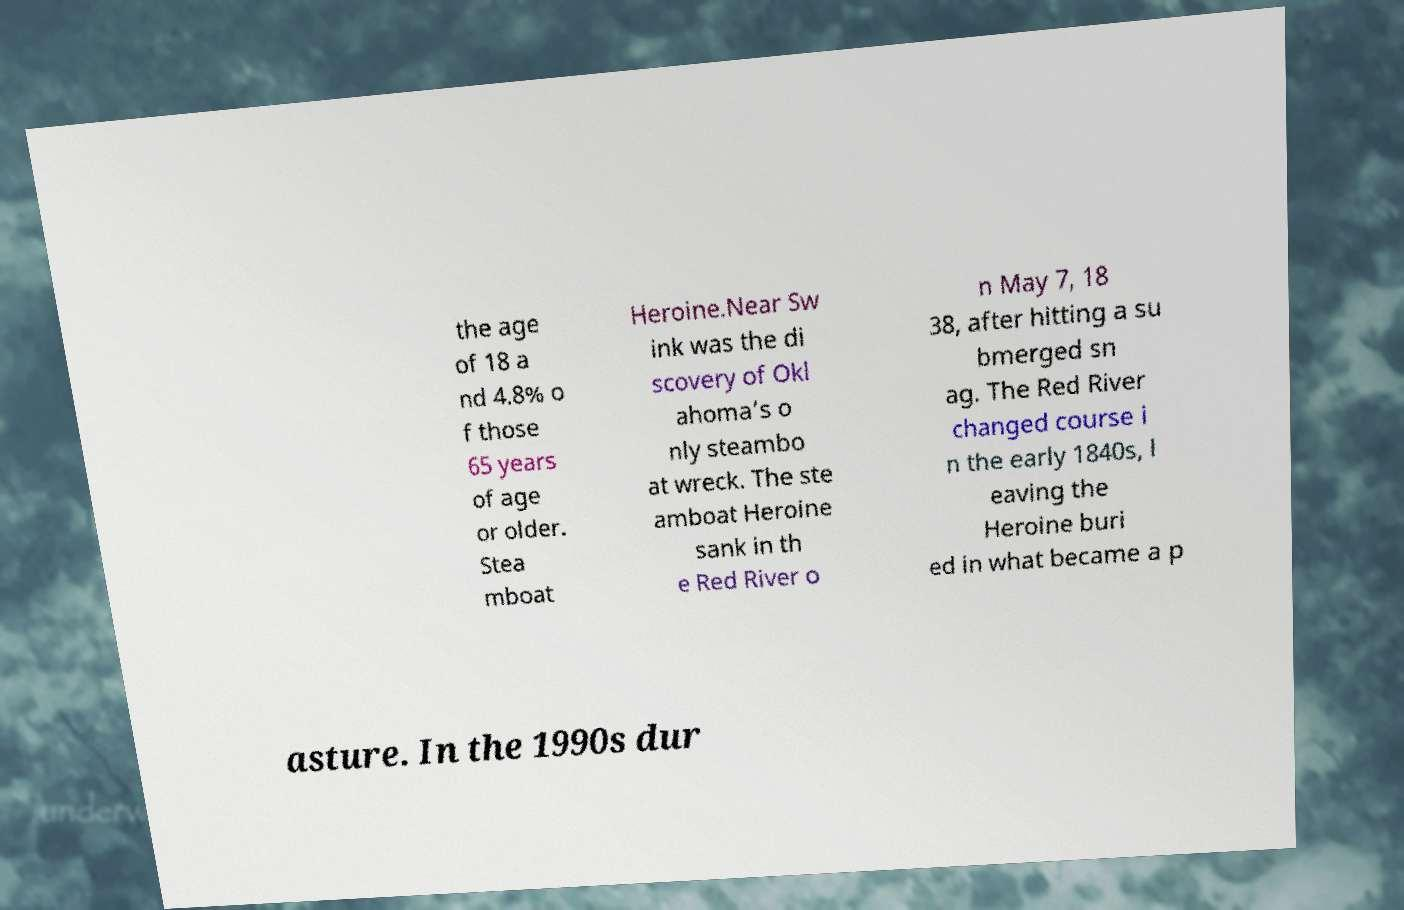Please identify and transcribe the text found in this image. the age of 18 a nd 4.8% o f those 65 years of age or older. Stea mboat Heroine.Near Sw ink was the di scovery of Okl ahoma’s o nly steambo at wreck. The ste amboat Heroine sank in th e Red River o n May 7, 18 38, after hitting a su bmerged sn ag. The Red River changed course i n the early 1840s, l eaving the Heroine buri ed in what became a p asture. In the 1990s dur 